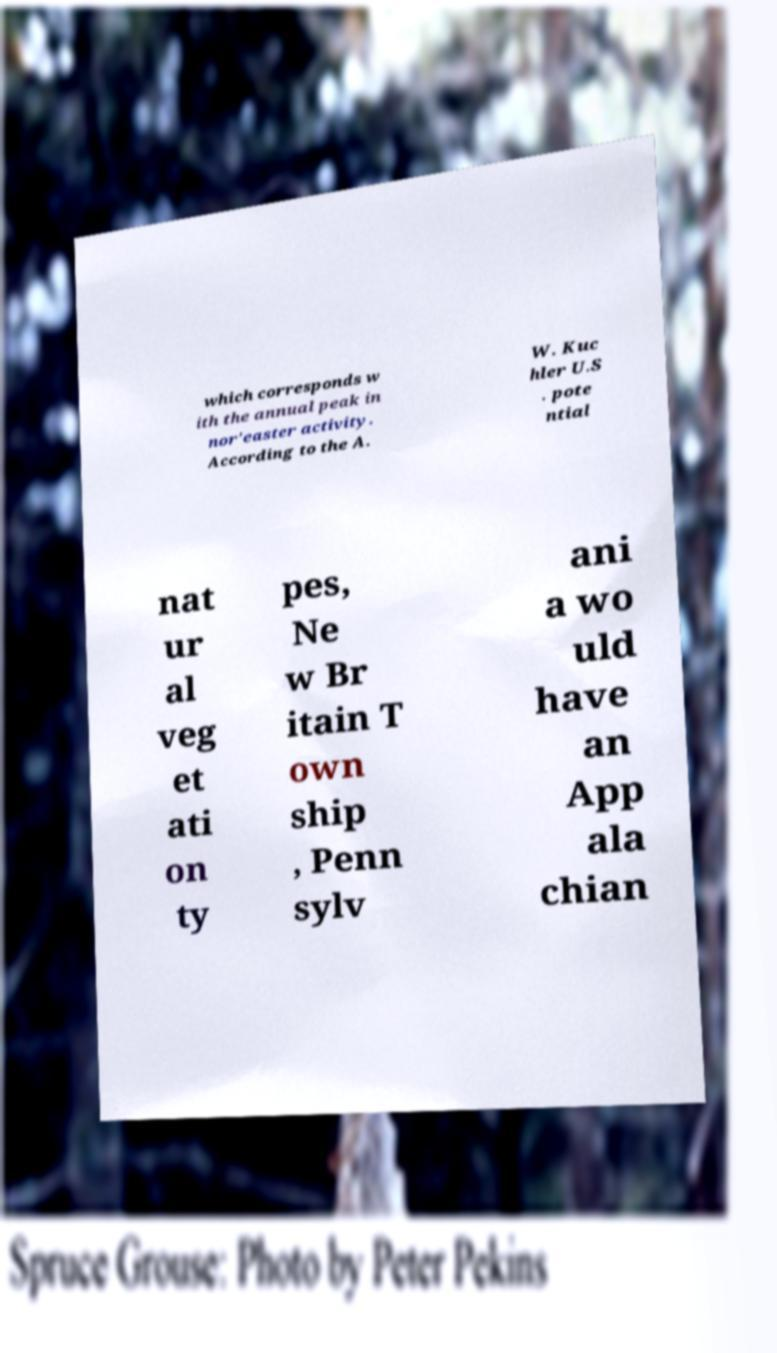Please identify and transcribe the text found in this image. which corresponds w ith the annual peak in nor'easter activity. According to the A. W. Kuc hler U.S . pote ntial nat ur al veg et ati on ty pes, Ne w Br itain T own ship , Penn sylv ani a wo uld have an App ala chian 